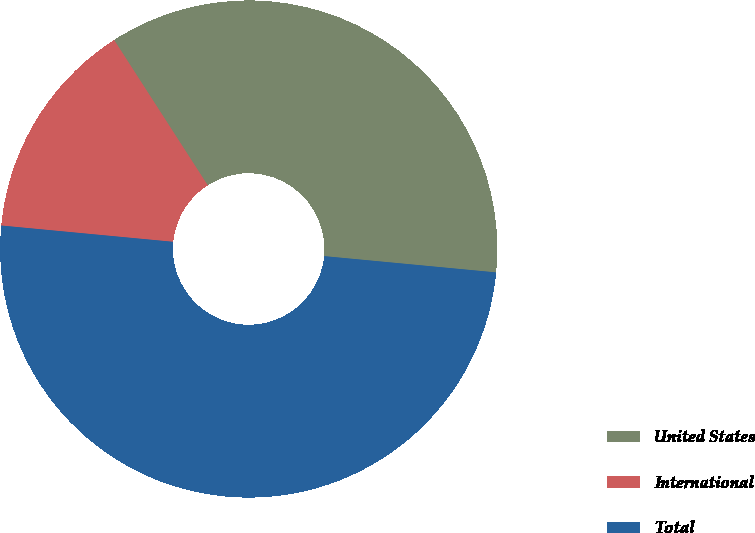Convert chart to OTSL. <chart><loc_0><loc_0><loc_500><loc_500><pie_chart><fcel>United States<fcel>International<fcel>Total<nl><fcel>35.61%<fcel>14.39%<fcel>50.0%<nl></chart> 